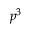Convert formula to latex. <formula><loc_0><loc_0><loc_500><loc_500>p ^ { 3 }</formula> 